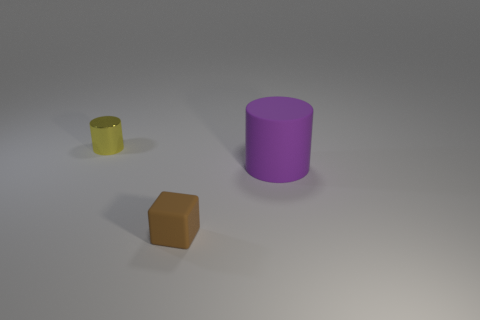Add 1 brown things. How many objects exist? 4 Subtract all yellow cylinders. How many cylinders are left? 1 Subtract 2 cylinders. How many cylinders are left? 0 Subtract all cylinders. How many objects are left? 1 Add 3 small yellow objects. How many small yellow objects are left? 4 Add 1 big gray rubber blocks. How many big gray rubber blocks exist? 1 Subtract 1 brown cubes. How many objects are left? 2 Subtract all cyan blocks. Subtract all purple balls. How many blocks are left? 1 Subtract all cyan cylinders. Subtract all cubes. How many objects are left? 2 